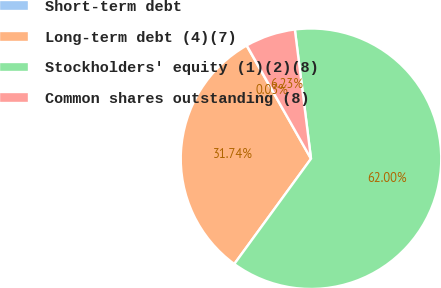Convert chart. <chart><loc_0><loc_0><loc_500><loc_500><pie_chart><fcel>Short-term debt<fcel>Long-term debt (4)(7)<fcel>Stockholders' equity (1)(2)(8)<fcel>Common shares outstanding (8)<nl><fcel>0.03%<fcel>31.74%<fcel>62.0%<fcel>6.23%<nl></chart> 